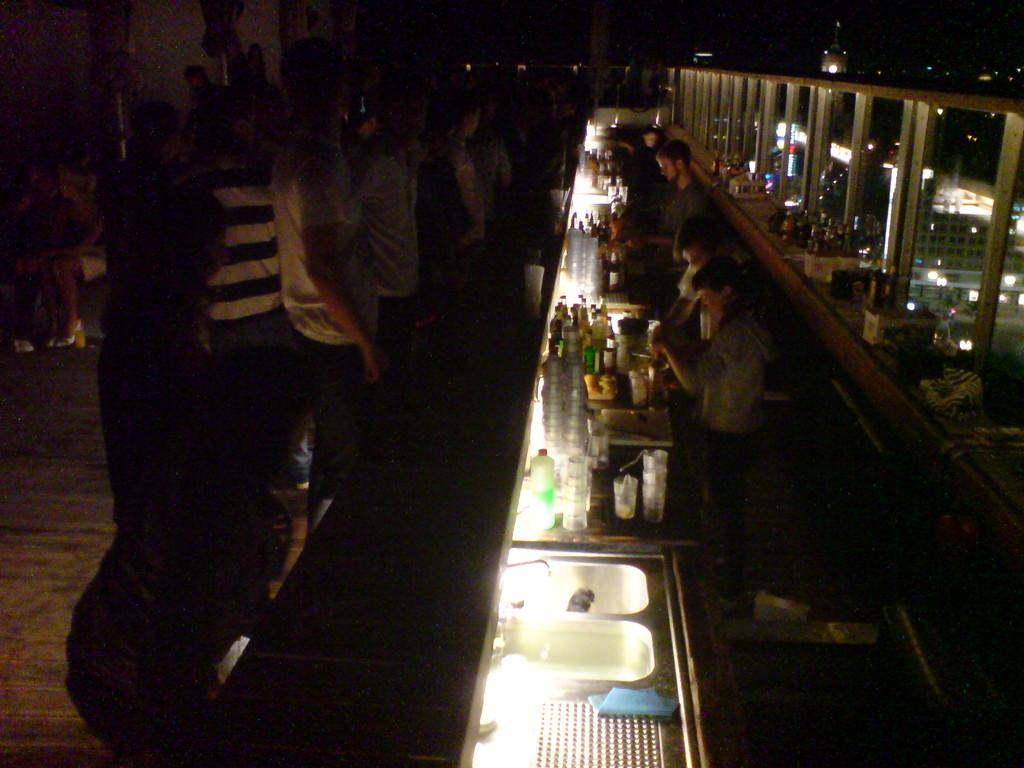How many people can be seen at the bottom of the image? There are many people at the bottom of the image. Where are the majority of people located in the image? There are many people on the left side of the image. What can be seen in the background of the image? In the background, there are lights, pillars, glass, buildings, tables, and people. How many snakes are crawling on the tables in the background of the image? There are no snakes present in the image; only people, lights, pillars, glass, buildings, and tables can be seen in the background. What type of sock is being used to plot the buildings in the image? There is no sock or plotting activity present in the image. 